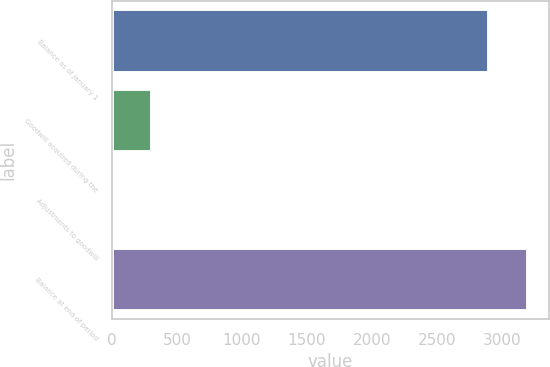<chart> <loc_0><loc_0><loc_500><loc_500><bar_chart><fcel>Balance as of January 1<fcel>Goodwill acquired during the<fcel>Adjustments to goodwill<fcel>Balance at end of period<nl><fcel>2901.7<fcel>307.59<fcel>5.9<fcel>3203.39<nl></chart> 